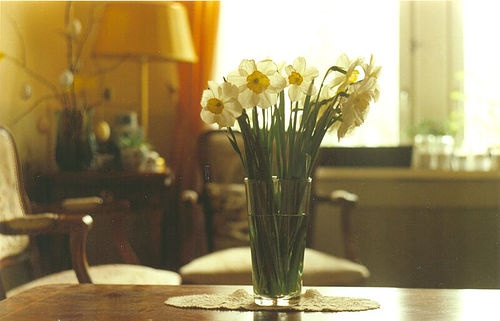Describe the objects in this image and their specific colors. I can see potted plant in lightyellow, darkgreen, black, khaki, and tan tones, chair in lightyellow, olive, black, and khaki tones, dining table in lightyellow, ivory, olive, and khaki tones, chair in lightyellow, black, gray, and khaki tones, and potted plant in lightyellow, olive, and black tones in this image. 